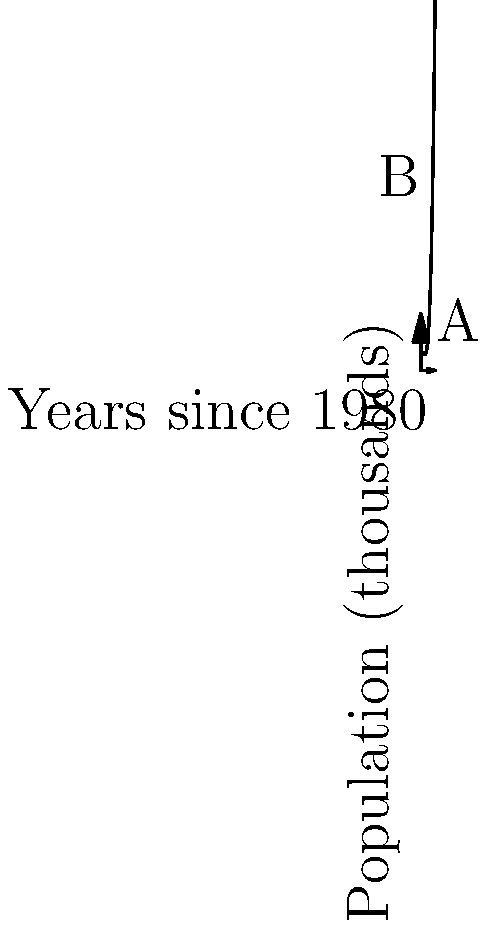The graph represents the population of Iranian immigrants in the United States (in thousands) since 1980. The x-axis shows years since 1980, and the y-axis shows the population. If the population function is given by $P(x) = 0.5x^3 - 3x^2 + 5x + 10$, calculate the change in the immigrant population between points A (2 years after 1980) and B (8 years after 1980). To find the change in population between points A and B, we need to:

1. Calculate the population at point A (x = 2):
   $P(2) = 0.5(2)^3 - 3(2)^2 + 5(2) + 10$
   $= 0.5(8) - 3(4) + 10 + 10$
   $= 4 - 12 + 20 = 12$ thousand

2. Calculate the population at point B (x = 8):
   $P(8) = 0.5(8)^3 - 3(8)^2 + 5(8) + 10$
   $= 0.5(512) - 3(64) + 40 + 10$
   $= 256 - 192 + 50 = 114$ thousand

3. Calculate the change in population:
   Change = Population at B - Population at A
   $= 114 - 12 = 102$ thousand

Therefore, the change in the Iranian immigrant population between points A and B is an increase of 102,000 people.
Answer: 102,000 